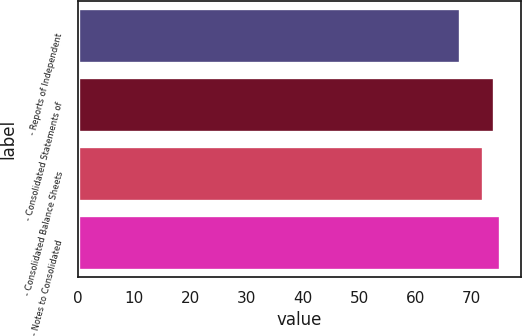Convert chart. <chart><loc_0><loc_0><loc_500><loc_500><bar_chart><fcel>- Reports of Independent<fcel>- Consolidated Statements of<fcel>- Consolidated Balance Sheets<fcel>- Notes to Consolidated<nl><fcel>68<fcel>74<fcel>72<fcel>75<nl></chart> 